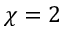<formula> <loc_0><loc_0><loc_500><loc_500>\chi = 2</formula> 